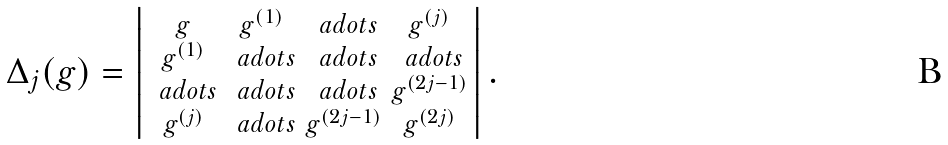Convert formula to latex. <formula><loc_0><loc_0><loc_500><loc_500>\Delta _ { j } ( g ) = \left | \begin{smallmatrix} g & g ^ { ( 1 ) } & \ a d o t s & g ^ { ( j ) } \\ g ^ { ( 1 ) } & \ a d o t s & \ a d o t s & \ a d o t s \\ \ a d o t s & \ a d o t s & \ a d o t s & g ^ { ( 2 j - 1 ) } \\ g ^ { ( j ) } & \ a d o t s & g ^ { ( 2 j - 1 ) } & g ^ { ( 2 j ) } \end{smallmatrix} \right | .</formula> 